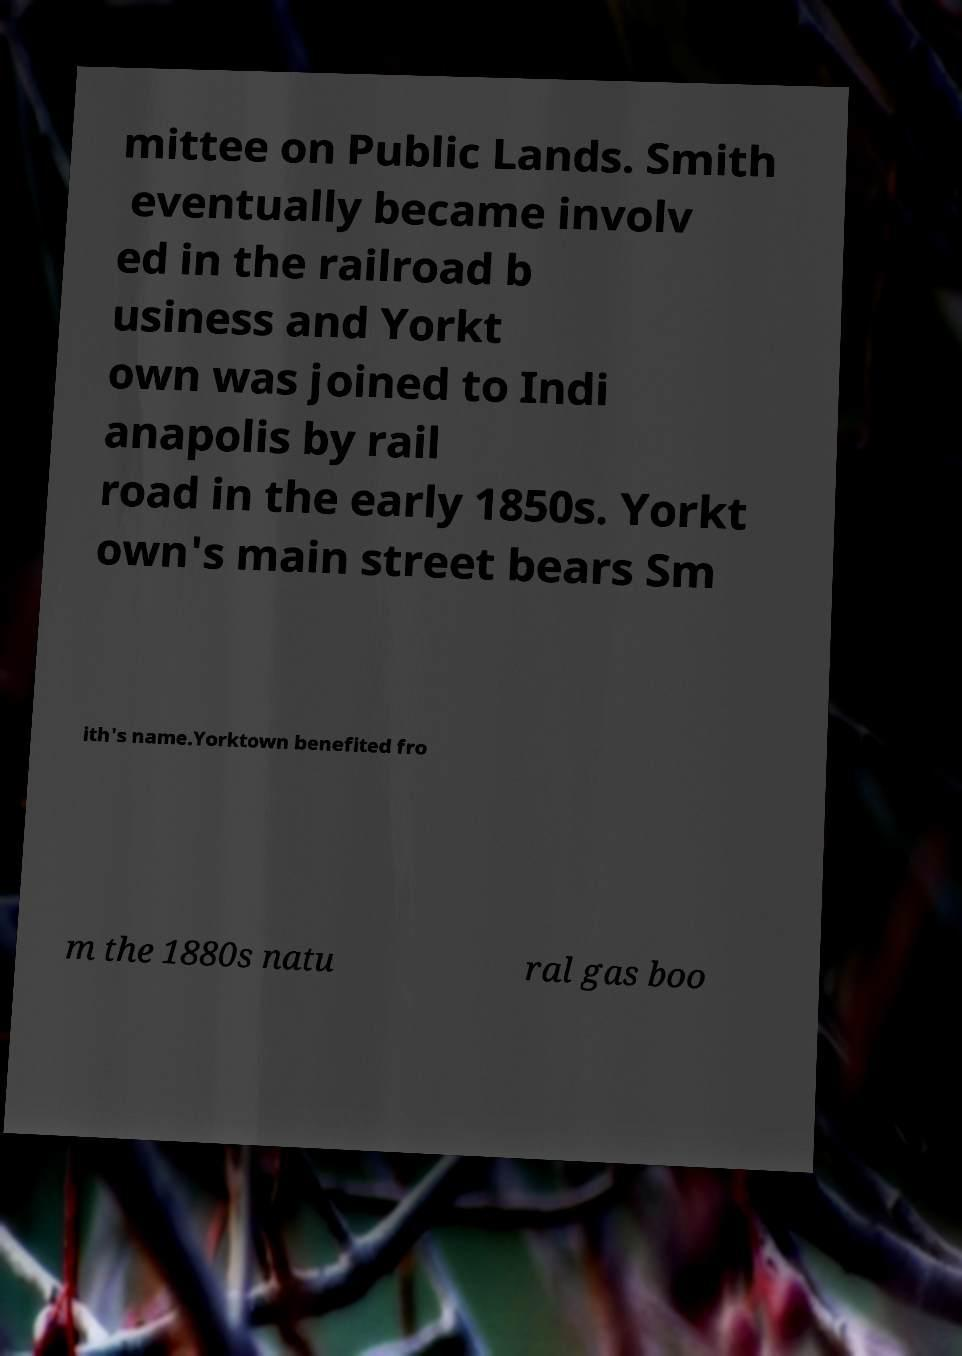What messages or text are displayed in this image? I need them in a readable, typed format. mittee on Public Lands. Smith eventually became involv ed in the railroad b usiness and Yorkt own was joined to Indi anapolis by rail road in the early 1850s. Yorkt own's main street bears Sm ith's name.Yorktown benefited fro m the 1880s natu ral gas boo 